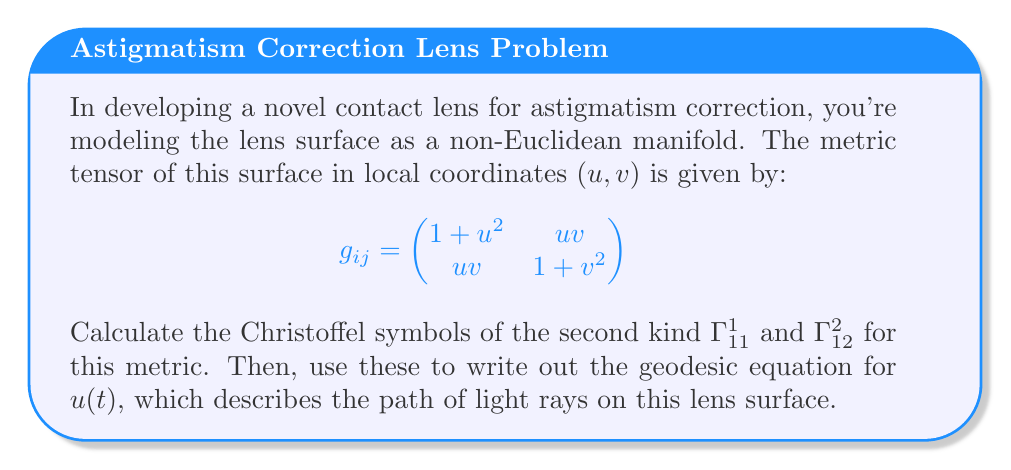Help me with this question. To solve this problem, we'll follow these steps:

1) First, we need to calculate the inverse metric tensor $g^{ij}$:

   $$g^{ij} = \frac{1}{det(g_{ij})} \begin{pmatrix}
   1+v^2 & -uv \\
   -uv & 1+u^2
   \end{pmatrix}$$

   where $det(g_{ij}) = (1+u^2)(1+v^2) - (uv)^2 = 1 + u^2 + v^2$

2) Now, we can calculate the Christoffel symbols using the formula:

   $$\Gamma^k_{ij} = \frac{1}{2}g^{km}(\partial_i g_{jm} + \partial_j g_{im} - \partial_m g_{ij})$$

3) For $\Gamma^1_{11}$:

   $$\begin{align*}
   \Gamma^1_{11} &= \frac{1}{2}g^{11}(\partial_1 g_{11} + \partial_1 g_{11} - \partial_1 g_{11}) + \frac{1}{2}g^{12}(\partial_1 g_{12} + \partial_1 g_{12} - \partial_2 g_{11}) \\
   &= \frac{1}{2}\frac{1+v^2}{1+u^2+v^2}(2u) + \frac{1}{2}\frac{-uv}{1+u^2+v^2}(v-0) \\
   &= \frac{u(1+v^2)-uv^2}{1+u^2+v^2} = \frac{u}{1+u^2+v^2}
   \end{align*}$$

4) For $\Gamma^2_{12}$:

   $$\begin{align*}
   \Gamma^2_{12} &= \frac{1}{2}g^{21}(\partial_1 g_{22} + \partial_2 g_{12} - \partial_2 g_{12}) + \frac{1}{2}g^{22}(\partial_1 g_{22} + \partial_2 g_{12} - \partial_1 g_{22}) \\
   &= \frac{1}{2}\frac{-uv}{1+u^2+v^2}(0+u-u) + \frac{1}{2}\frac{1+u^2}{1+u^2+v^2}(0+u-0) \\
   &= \frac{u(1+u^2)}{2(1+u^2+v^2)}
   \end{align*}$$

5) The geodesic equation for $u(t)$ is:

   $$\frac{d^2u}{dt^2} + \Gamma^1_{11}\left(\frac{du}{dt}\right)^2 + 2\Gamma^1_{12}\frac{du}{dt}\frac{dv}{dt} + \Gamma^1_{22}\left(\frac{dv}{dt}\right)^2 = 0$$

6) Substituting the Christoffel symbol we calculated and the other one we need:

   $$\frac{d^2u}{dt^2} + \frac{u}{1+u^2+v^2}\left(\frac{du}{dt}\right)^2 + 2\frac{u(1+u^2)}{2(1+u^2+v^2)}\frac{du}{dt}\frac{dv}{dt} + \Gamma^1_{22}\left(\frac{dv}{dt}\right)^2 = 0$$

This is the geodesic equation for $u(t)$, describing the path of light rays on the lens surface.
Answer: $$\frac{d^2u}{dt^2} + \frac{u}{1+u^2+v^2}\left(\frac{du}{dt}\right)^2 + \frac{u(1+u^2)}{1+u^2+v^2}\frac{du}{dt}\frac{dv}{dt} + \Gamma^1_{22}\left(\frac{dv}{dt}\right)^2 = 0$$ 